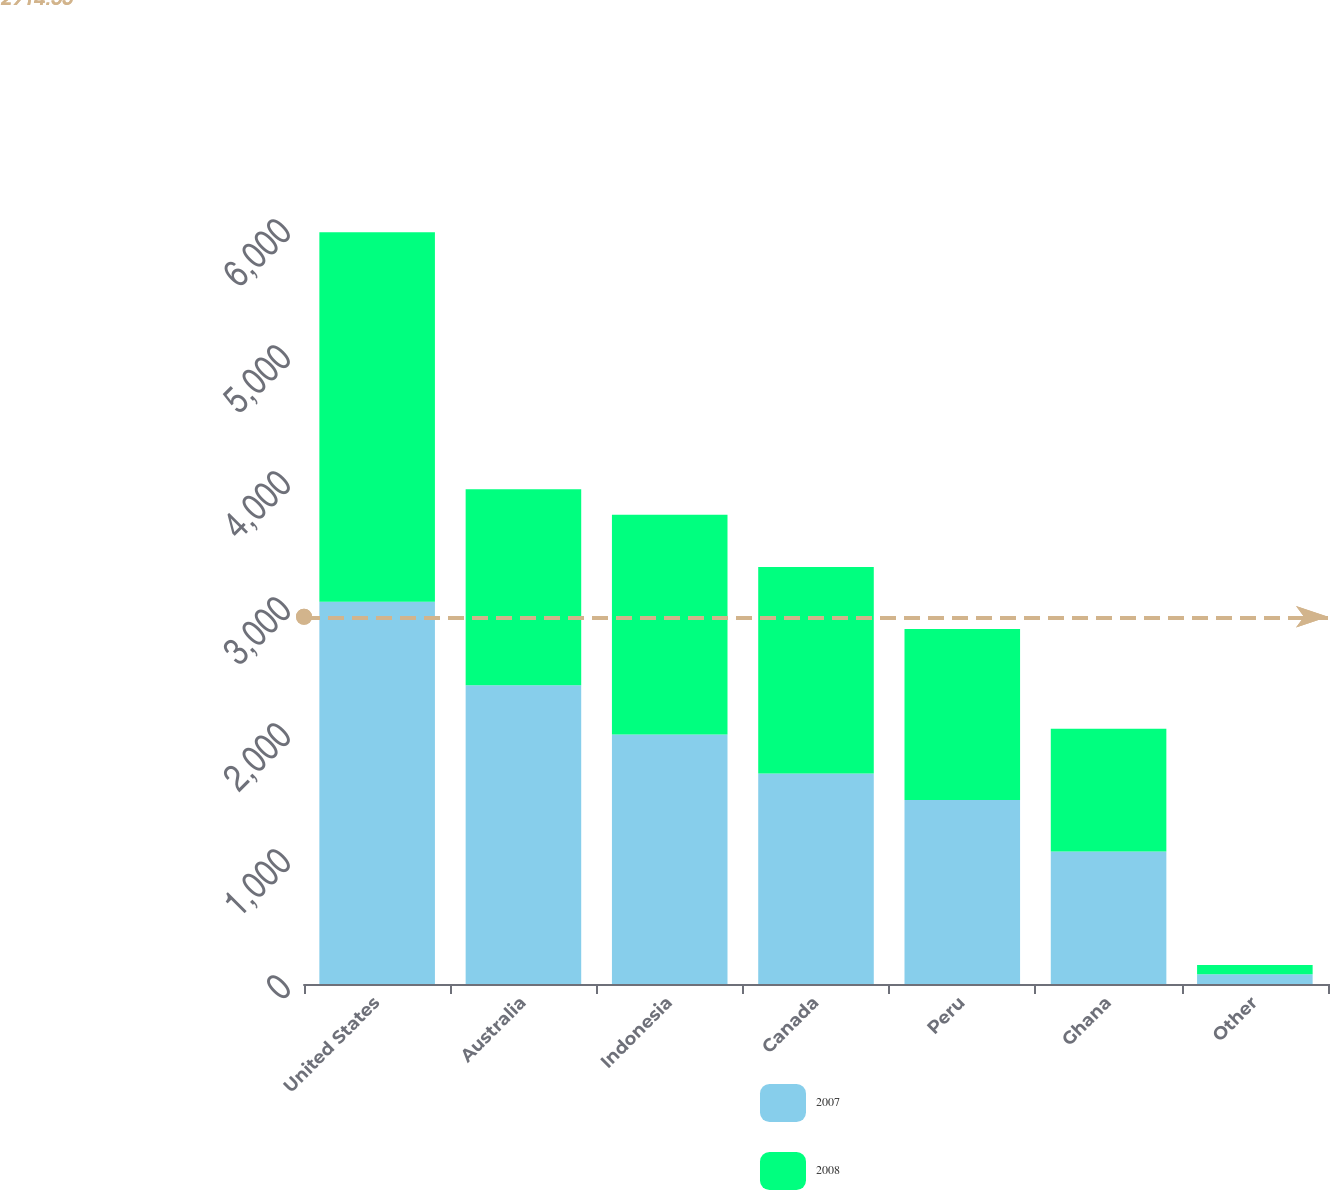<chart> <loc_0><loc_0><loc_500><loc_500><stacked_bar_chart><ecel><fcel>United States<fcel>Australia<fcel>Indonesia<fcel>Canada<fcel>Peru<fcel>Ghana<fcel>Other<nl><fcel>2007<fcel>3034<fcel>2371<fcel>1980<fcel>1671<fcel>1461<fcel>1051<fcel>77<nl><fcel>2008<fcel>2932<fcel>1555<fcel>1744<fcel>1639<fcel>1357<fcel>974<fcel>74<nl></chart> 